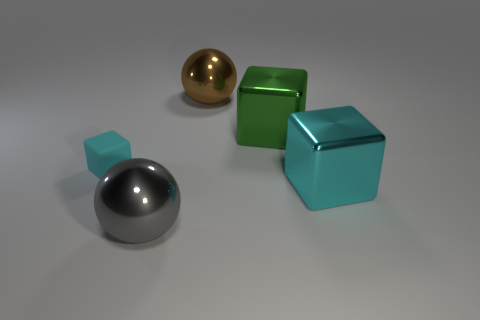Add 2 tiny cubes. How many objects exist? 7 Subtract all small rubber blocks. How many blocks are left? 2 Subtract all green blocks. How many blocks are left? 2 Subtract all spheres. How many objects are left? 3 Subtract 2 blocks. How many blocks are left? 1 Subtract all red balls. Subtract all red cubes. How many balls are left? 2 Subtract all yellow cylinders. How many green blocks are left? 1 Subtract all green matte things. Subtract all rubber things. How many objects are left? 4 Add 3 cubes. How many cubes are left? 6 Add 4 gray cubes. How many gray cubes exist? 4 